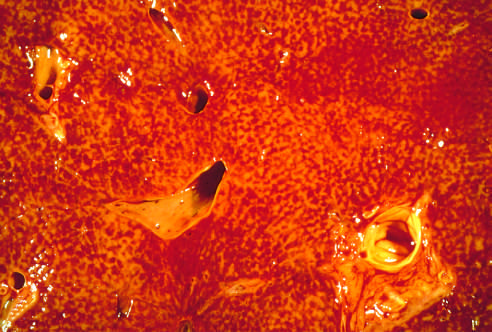what is notable for a variegated mottled red appearance, representing congestion and hemorrhage in the centrilobular regions of the parenchyma?
Answer the question using a single word or phrase. The cut liver section 